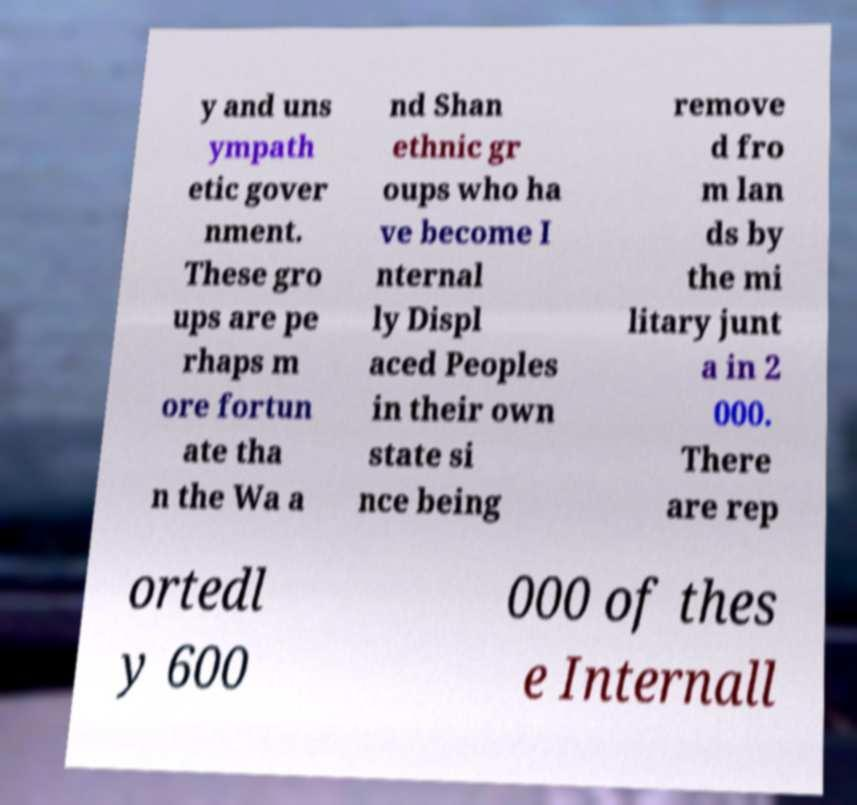Could you extract and type out the text from this image? y and uns ympath etic gover nment. These gro ups are pe rhaps m ore fortun ate tha n the Wa a nd Shan ethnic gr oups who ha ve become I nternal ly Displ aced Peoples in their own state si nce being remove d fro m lan ds by the mi litary junt a in 2 000. There are rep ortedl y 600 000 of thes e Internall 